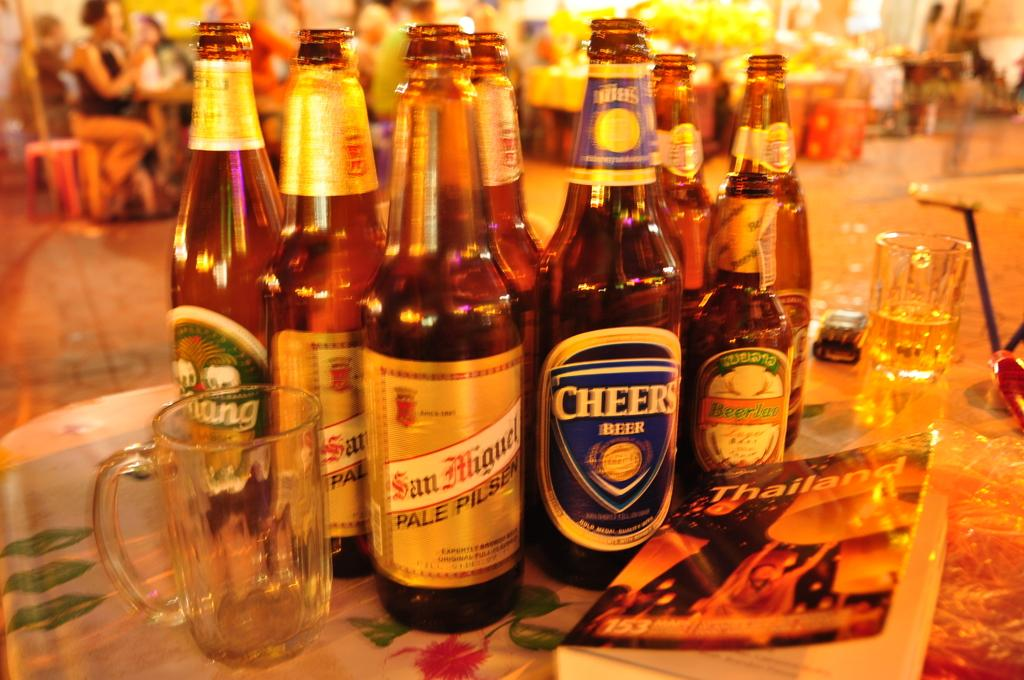What type of containers are visible in the image? There are bottles and glasses in the image. What other object can be seen on the table in the image? There is a book in the image. Where are these objects located? The objects are on a table. What type of bucket is used to hear the mailbox in the image? There is no bucket, hearing, or mailbox present in the image. 